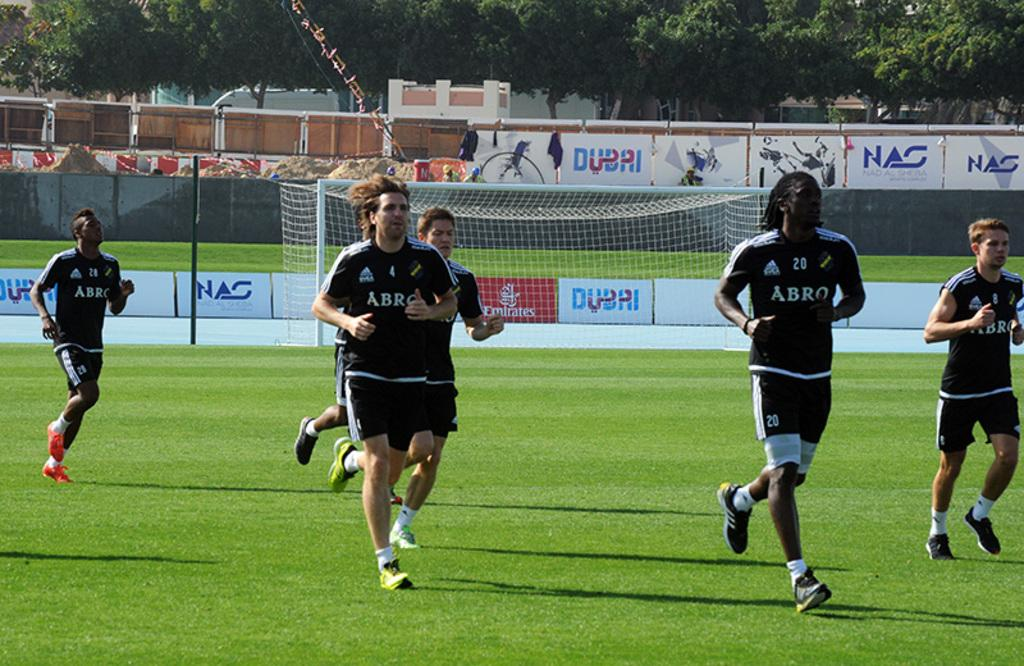<image>
Render a clear and concise summary of the photo. 6 soccer players run next to each other with Abro jerseys on with advertisements in the background. 